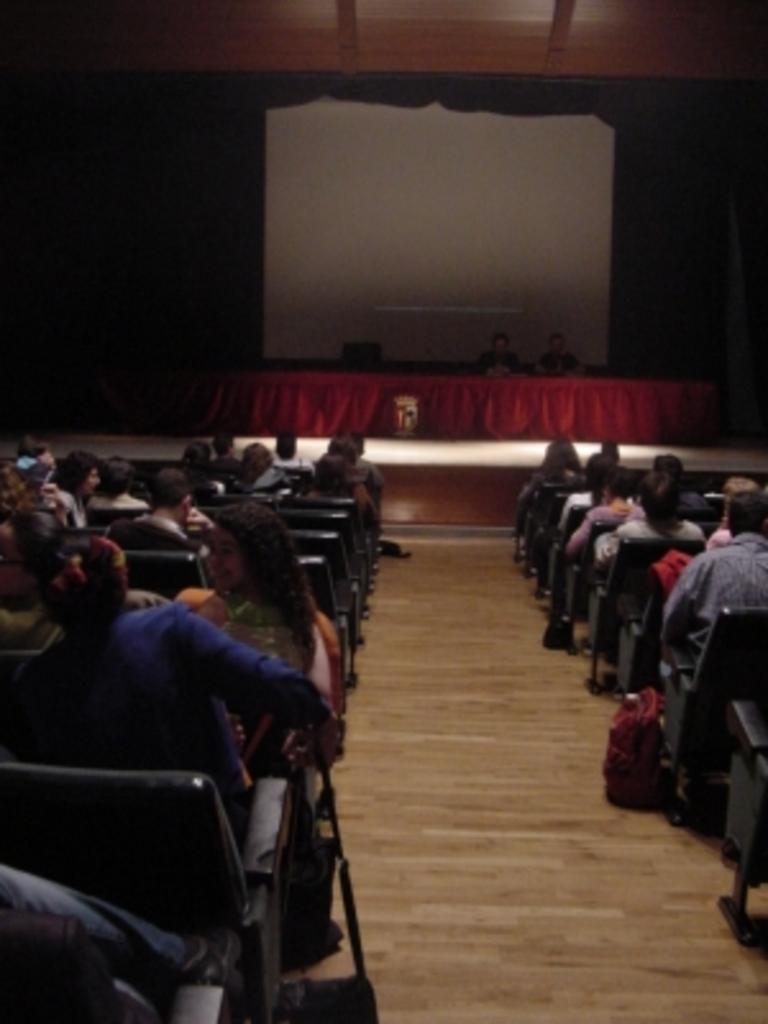Could you give a brief overview of what you see in this image? In this image there is floor at the bottom. There are chairs, people on the left and right corner. There is a table, chairs, people in the foreground. And there is a screen in the background. 